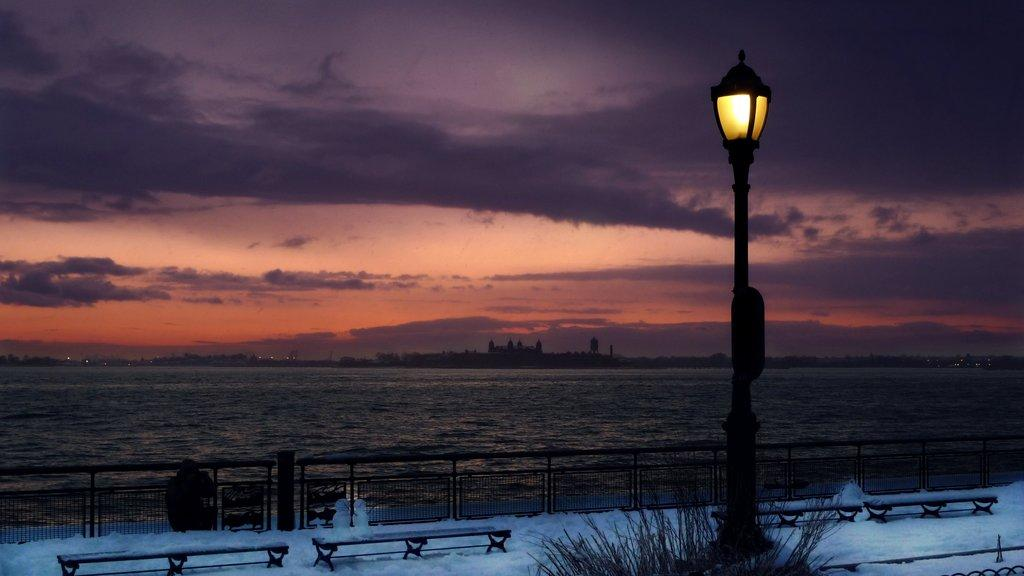What is one of the main structures in the image? There is a pole in the image. What other objects can be seen in the image? There is a fence, benches on snow, trees, and water visible in the image. Can you describe the background of the image? The sky with clouds is visible in the background of the image. How many lines can be seen on the thumb in the image? There are no thumbs or lines present in the image. What type of trick is being performed with the water in the image? There is no trick being performed with the water in the image; it is simply visible. 